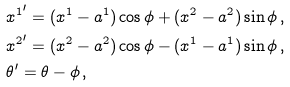Convert formula to latex. <formula><loc_0><loc_0><loc_500><loc_500>& { x ^ { 1 } } ^ { \prime } = ( x ^ { 1 } - a ^ { 1 } ) \cos \phi + ( x ^ { 2 } - a ^ { 2 } ) \sin \phi \, , \\ & { x ^ { 2 } } ^ { \prime } = ( x ^ { 2 } - a ^ { 2 } ) \cos \phi - ( x ^ { 1 } - a ^ { 1 } ) \sin \phi \, , \\ & \theta ^ { \prime } = \theta - \phi \, ,</formula> 